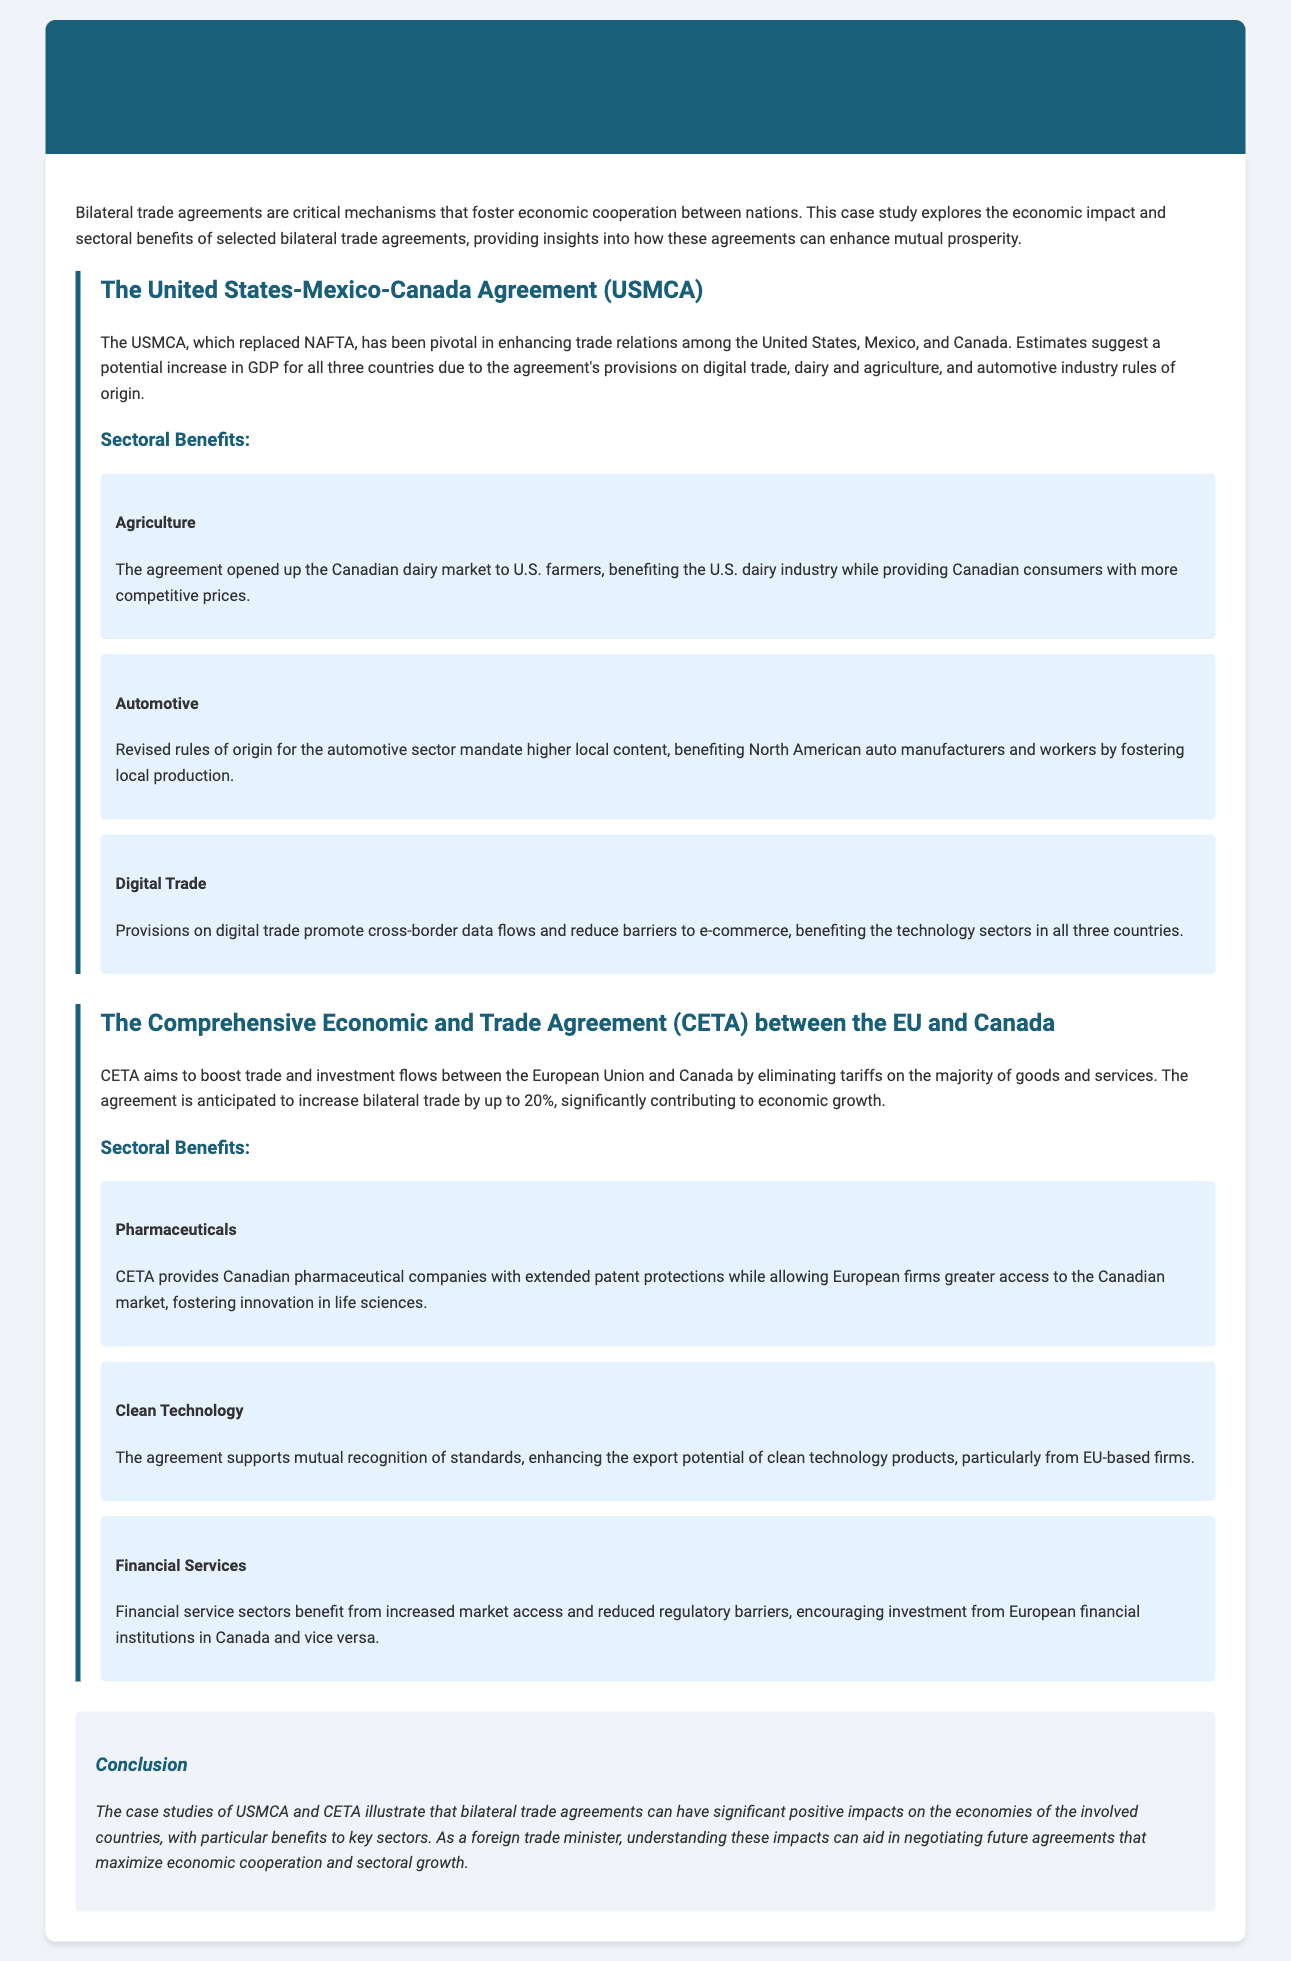What is the main purpose of bilateral trade agreements? The document states that bilateral trade agreements are critical mechanisms that foster economic cooperation between nations.
Answer: Economic cooperation What countries are involved in the USMCA? The United States-Mexico-Canada Agreement includes the United States, Mexico, and Canada.
Answer: United States, Mexico, Canada What sector benefits from revised rules of origin in the USMCA? The automotive sector benefits from revised rules of origin that mandate higher local content.
Answer: Automotive What is the anticipated increase in bilateral trade due to CETA? The Comprehensive Economic and Trade Agreement aims to increase bilateral trade by up to 20%.
Answer: 20% Which sector is supported by mutual recognition of standards in CETA? The clean technology sector is supported by mutual recognition of standards in CETA.
Answer: Clean Technology What benefit does CETA provide to Canadian pharmaceutical companies? CETA provides Canadian pharmaceutical companies with extended patent protections.
Answer: Extended patent protections What does the USMCA promote in the technology sectors? The USMCA promotes cross-border data flows and reduces barriers to e-commerce.
Answer: Cross-border data flows What is a key benefit of CETA for financial services? CETA encourages investment from European financial institutions in Canada and vice versa.
Answer: Increased market access What were the expected outcomes of the USMCA on GDP? Estimates suggest a potential increase in GDP for all three countries.
Answer: Increase in GDP 